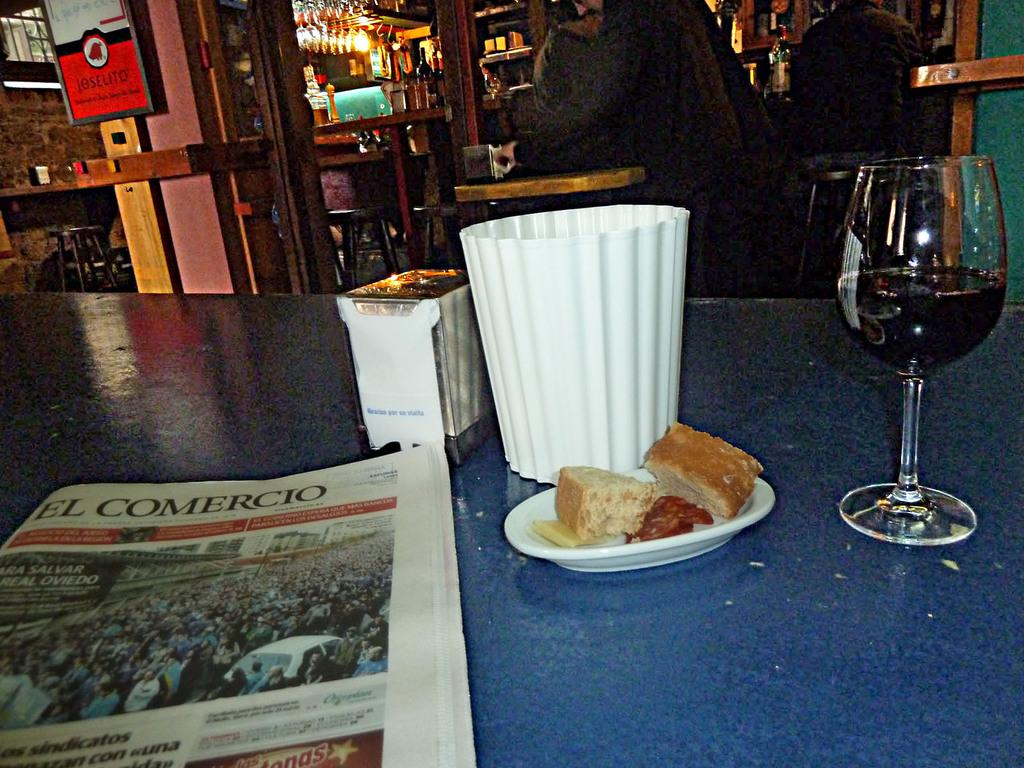<image>
Summarize the visual content of the image. The El Comercio newspaper sits on a blue table next to some food and a glass of wine. 